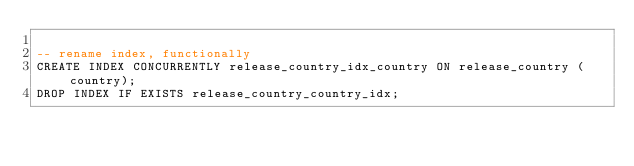<code> <loc_0><loc_0><loc_500><loc_500><_SQL_>
-- rename index, functionally
CREATE INDEX CONCURRENTLY release_country_idx_country ON release_country (country);
DROP INDEX IF EXISTS release_country_country_idx;
</code> 